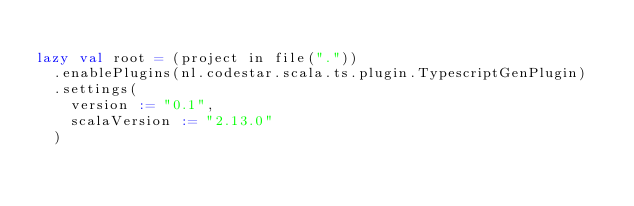Convert code to text. <code><loc_0><loc_0><loc_500><loc_500><_Scala_>
lazy val root = (project in file("."))
  .enablePlugins(nl.codestar.scala.ts.plugin.TypescriptGenPlugin)
  .settings(
    version := "0.1",
    scalaVersion := "2.13.0"
  )
</code> 